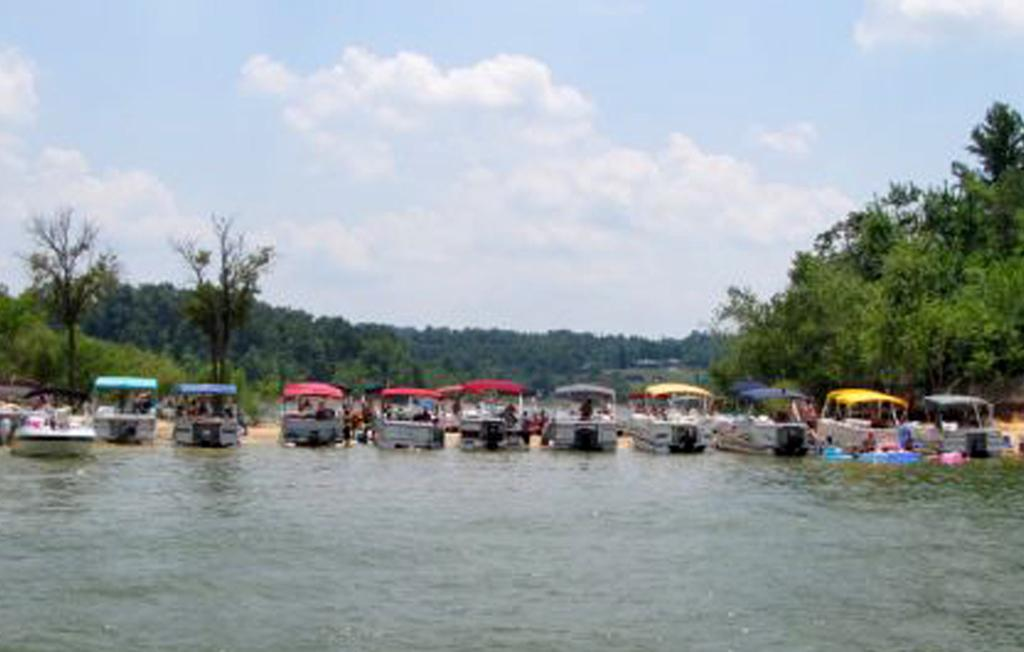What is on the water in the image? There are boats on the water in the image. Who is in the boats? There are people sitting in the boats. What can be seen in the background of the image? There are trees in the background of the image. What is the color of the trees? The trees are green in color. What is visible above the water and trees in the image? The sky is visible in the image. What colors can be seen in the sky? The sky has both white and blue colors. Where is the basket located in the image? There is no basket present in the image. What is the value of the quarter in the image? There is no quarter present in the image. 